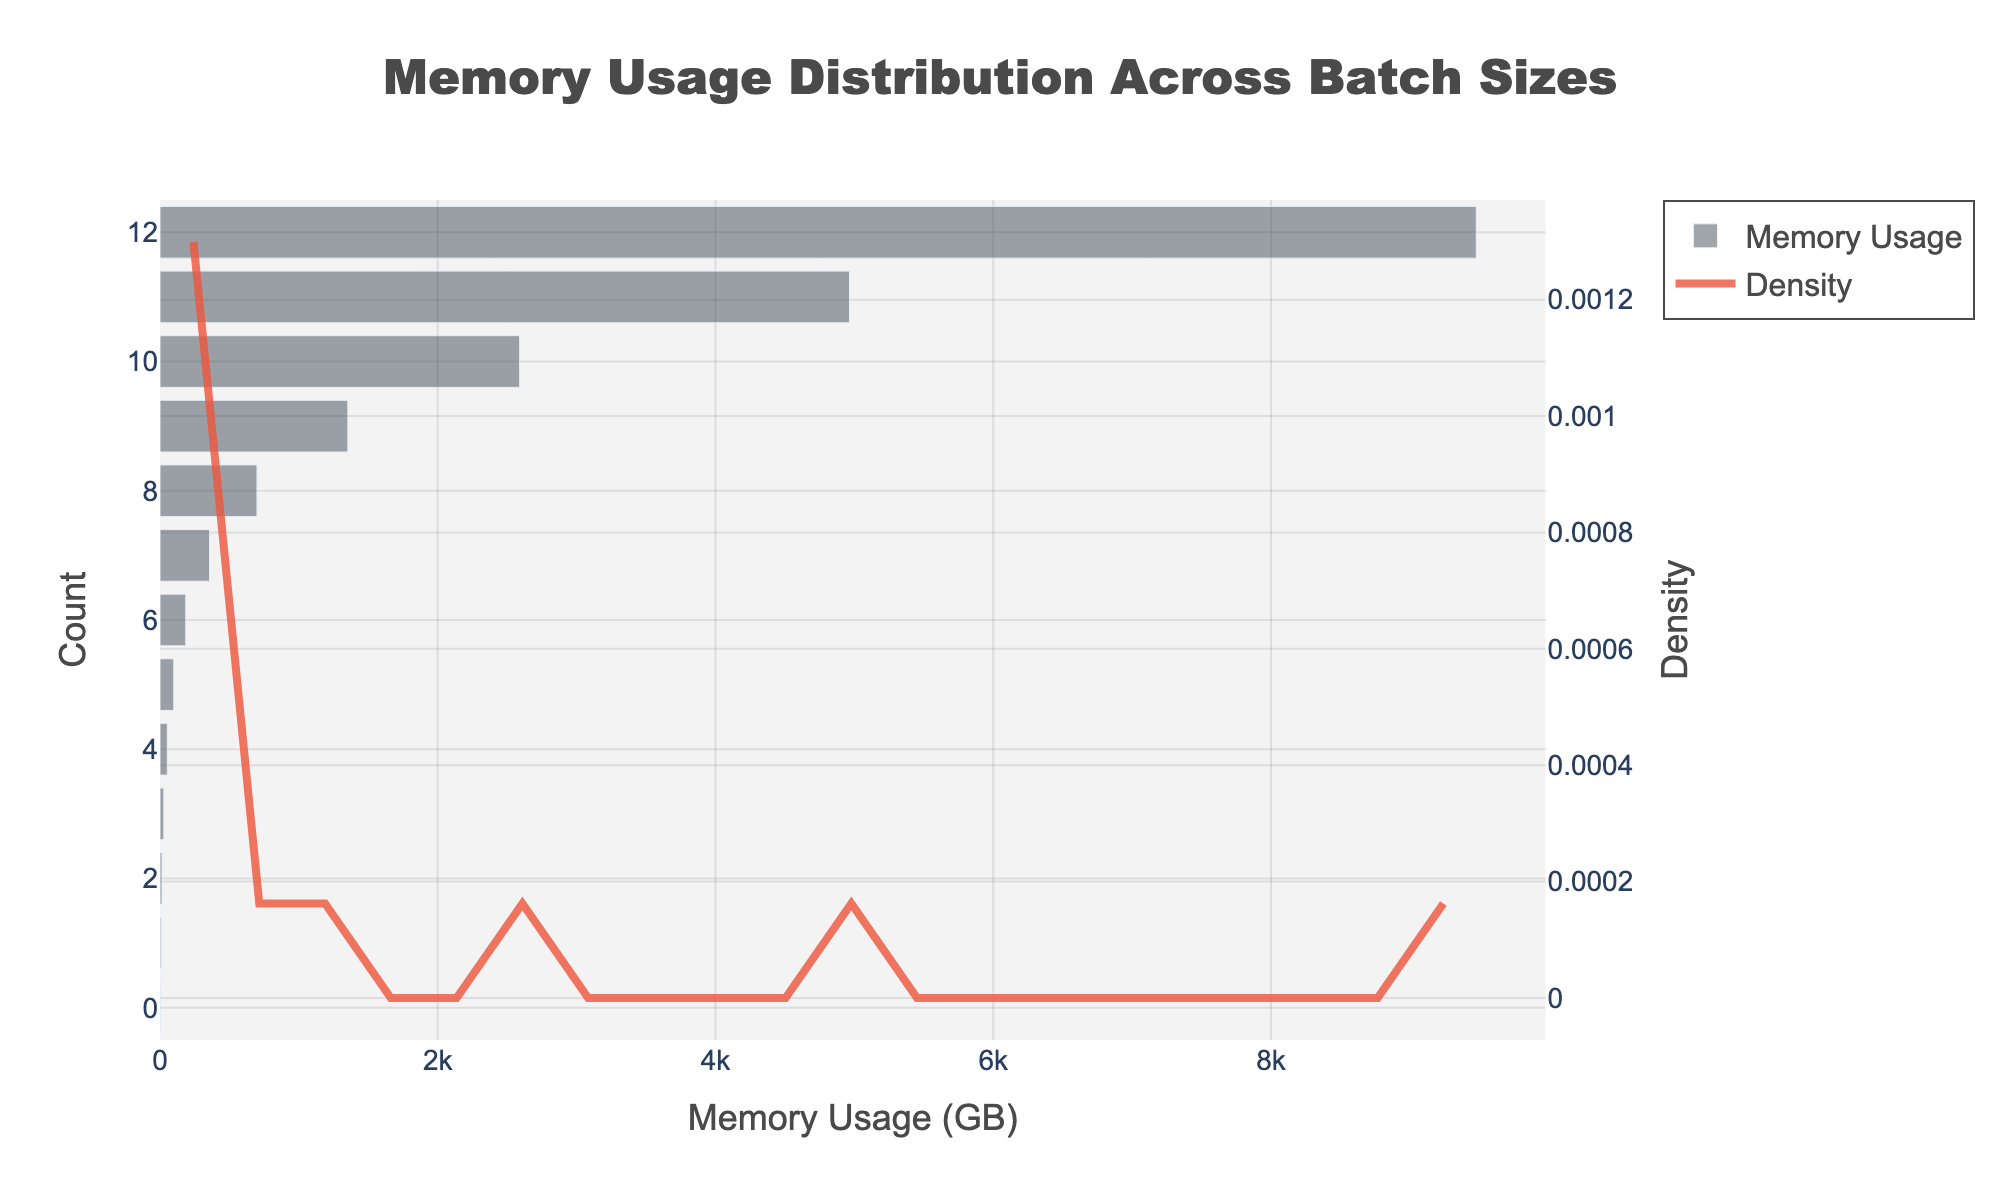What is the title of the figure? The title is typically found at the top of the figure and describes the main content.
Answer: Memory Usage Distribution Across Batch Sizes What does the x-axis represent? The x-axis label is shown below the horizontal axis and indicates what variable is being measured.
Answer: Memory Usage (GB) What colors are used for the histogram bars and the KDE line? These colors help visually distinguish between the histogram and the KDE.
Answer: Bars: dark gray, KDE: reddish-orange How many data points are there in the histogram? Each bar in the histogram represents a data point; counting these will give the total number of data points.
Answer: 13 Which batch size corresponds to the maximum memory usage? Find the value on the x-axis that has the highest corresponding bar.
Answer: 65536 What is the approximate memory usage value where the KDE peaks? Locate the highest point on the KDE curve and trace it back to the x-axis.
Answer: ~185.4 GB How does memory usage change as batch size increases? By observing the histogram bars from left to right, you can infer the trend.
Answer: Increases exponentially What is the range of memory usage values in this dataset? Identify the smallest and largest values on the x-axis covered by the histogram bars.
Answer: 4.2 GB to 9478.6 GB Which visual element provides the density distribution of memory usage? The KDE line placed on the histogram indicates the distribution density.
Answer: KDE (density curve) Compare the memory usage between batch sizes 1024 and 2048. Find the histogram bars corresponding to these batch sizes and compare their heights.
Answer: 2048 has higher memory usage 